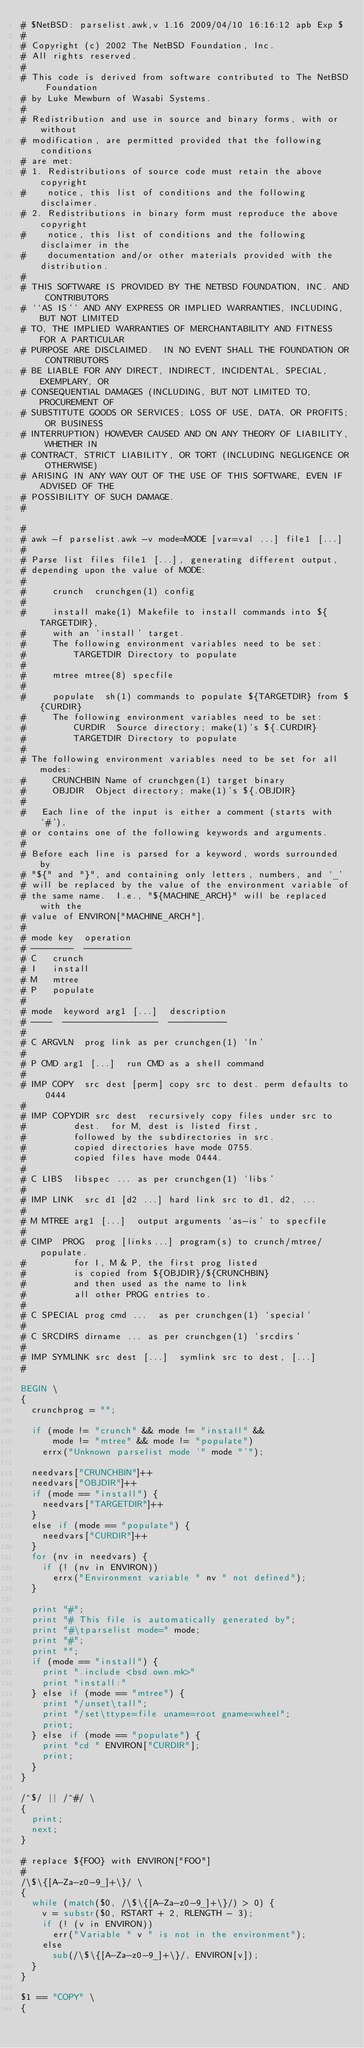<code> <loc_0><loc_0><loc_500><loc_500><_Awk_>#	$NetBSD: parselist.awk,v 1.16 2009/04/10 16:16:12 apb Exp $
#
# Copyright (c) 2002 The NetBSD Foundation, Inc.
# All rights reserved.
#
# This code is derived from software contributed to The NetBSD Foundation
# by Luke Mewburn of Wasabi Systems.
#
# Redistribution and use in source and binary forms, with or without
# modification, are permitted provided that the following conditions
# are met:
# 1. Redistributions of source code must retain the above copyright
#    notice, this list of conditions and the following disclaimer.
# 2. Redistributions in binary form must reproduce the above copyright
#    notice, this list of conditions and the following disclaimer in the
#    documentation and/or other materials provided with the distribution.
#
# THIS SOFTWARE IS PROVIDED BY THE NETBSD FOUNDATION, INC. AND CONTRIBUTORS
# ``AS IS'' AND ANY EXPRESS OR IMPLIED WARRANTIES, INCLUDING, BUT NOT LIMITED
# TO, THE IMPLIED WARRANTIES OF MERCHANTABILITY AND FITNESS FOR A PARTICULAR
# PURPOSE ARE DISCLAIMED.  IN NO EVENT SHALL THE FOUNDATION OR CONTRIBUTORS
# BE LIABLE FOR ANY DIRECT, INDIRECT, INCIDENTAL, SPECIAL, EXEMPLARY, OR
# CONSEQUENTIAL DAMAGES (INCLUDING, BUT NOT LIMITED TO, PROCUREMENT OF
# SUBSTITUTE GOODS OR SERVICES; LOSS OF USE, DATA, OR PROFITS; OR BUSINESS
# INTERRUPTION) HOWEVER CAUSED AND ON ANY THEORY OF LIABILITY, WHETHER IN
# CONTRACT, STRICT LIABILITY, OR TORT (INCLUDING NEGLIGENCE OR OTHERWISE)
# ARISING IN ANY WAY OUT OF THE USE OF THIS SOFTWARE, EVEN IF ADVISED OF THE
# POSSIBILITY OF SUCH DAMAGE.
#

#
# awk -f parselist.awk -v mode=MODE [var=val ...] file1 [...]
#
#	Parse list files file1 [...], generating different output,
#	depending upon the value of MODE:
#
#	    crunch	crunchgen(1) config
#
#	    install	make(1) Makefile to install commands into ${TARGETDIR},
#			with an `install' target.
#			The following environment variables need to be set:
#			    TARGETDIR	Directory to populate
#
#	    mtree	mtree(8) specfile
#
#	    populate	sh(1) commands to populate ${TARGETDIR} from ${CURDIR}
#			The following environment variables need to be set:
#			    CURDIR	Source directory; make(1)'s ${.CURDIR}
#			    TARGETDIR	Directory to populate
#
#	The following environment variables need to be set for all modes:
#	    CRUNCHBIN	Name of crunchgen(1) target binary
#	    OBJDIR	Object directory; make(1)'s ${.OBJDIR}
#
# 	Each line of the input is either a comment (starts with `#'),
#	or contains one of the following keywords and arguments.
#
#	Before each line is parsed for a keyword, words surrounded by
#	"${" and "}", and containing only letters, numbers, and `_'
#	will be replaced by the value of the environment variable of
#	the same name.  I.e., "${MACHINE_ARCH}" will be replaced with the
#	value of ENVIRON["MACHINE_ARCH"].
#
#	mode key	operation
#	--------	---------
#	C		crunch
#	I		install
#	M		mtree
#	P		populate
#
#	mode	keyword arg1 [...]	description
#	----	------------------	-----------
#
#	C	ARGVLN	prog link	as per crunchgen(1) `ln'
#
#	P	CMD	arg1 [...]	run CMD as a shell command
#
#	IMP	COPY	src dest [perm]	copy src to dest. perm defaults to 0444
#
#	IMP	COPYDIR	src dest	recursively copy files under src to
#					dest.  for M, dest is listed first,
#					followed by the subdirectories in src.
#					copied directories have mode 0755.
#					copied files have mode 0444.
#
#	C	LIBS	libspec ...	as per crunchgen(1) `libs'
#
#	IMP	LINK	src d1 [d2 ...]	hard link src to d1, d2, ...
#
#	M	MTREE	arg1 [...]	output arguments `as-is' to specfile
#
#	CIMP	PROG	prog [links...]	program(s) to crunch/mtree/populate.
#					for I, M & P, the first prog listed
#					is copied from ${OBJDIR}/${CRUNCHBIN}
#					and then used as the name to link
#					all other PROG entries to.
#
#	C	SPECIAL	prog cmd ...	as per crunchgen(1) `special'
#
#	C	SRCDIRS	dirname ...	as per crunchgen(1) `srcdirs'
#
#	IMP	SYMLINK src dest [...]	symlink src to dest, [...]
#

BEGIN \
{
	crunchprog = "";

	if (mode != "crunch" && mode != "install" &&
	    mode != "mtree" && mode != "populate")
		errx("Unknown parselist mode '" mode "'");

	needvars["CRUNCHBIN"]++
	needvars["OBJDIR"]++
	if (mode == "install") {
		needvars["TARGETDIR"]++
	}
	else if (mode == "populate") {
		needvars["CURDIR"]++
	}
	for (nv in needvars) {
		if (! (nv in ENVIRON))
			errx("Environment variable " nv " not defined");
	}

	print "#";
	print "# This file is automatically generated by";
	print "#\tparselist mode=" mode;
	print "#";
	print "";
	if (mode == "install") {
		print ".include <bsd.own.mk>"
		print "install:"
	} else if (mode == "mtree") {
		print "/unset\tall";
		print "/set\ttype=file uname=root gname=wheel";
		print;
	} else if (mode == "populate") {
		print "cd " ENVIRON["CURDIR"];
		print;
	}
}

/^$/ || /^#/ \
{
	print;
	next;
}

#	replace ${FOO} with ENVIRON["FOO"]
#
/\$\{[A-Za-z0-9_]+\}/ \
{
	while (match($0, /\$\{[A-Za-z0-9_]+\}/) > 0) {
		v = substr($0, RSTART + 2, RLENGTH - 3);
		if (! (v in ENVIRON))
			err("Variable " v " is not in the environment");
		else
			sub(/\$\{[A-Za-z0-9_]+\}/, ENVIRON[v]);
	}
}

$1 == "COPY" \
{</code> 